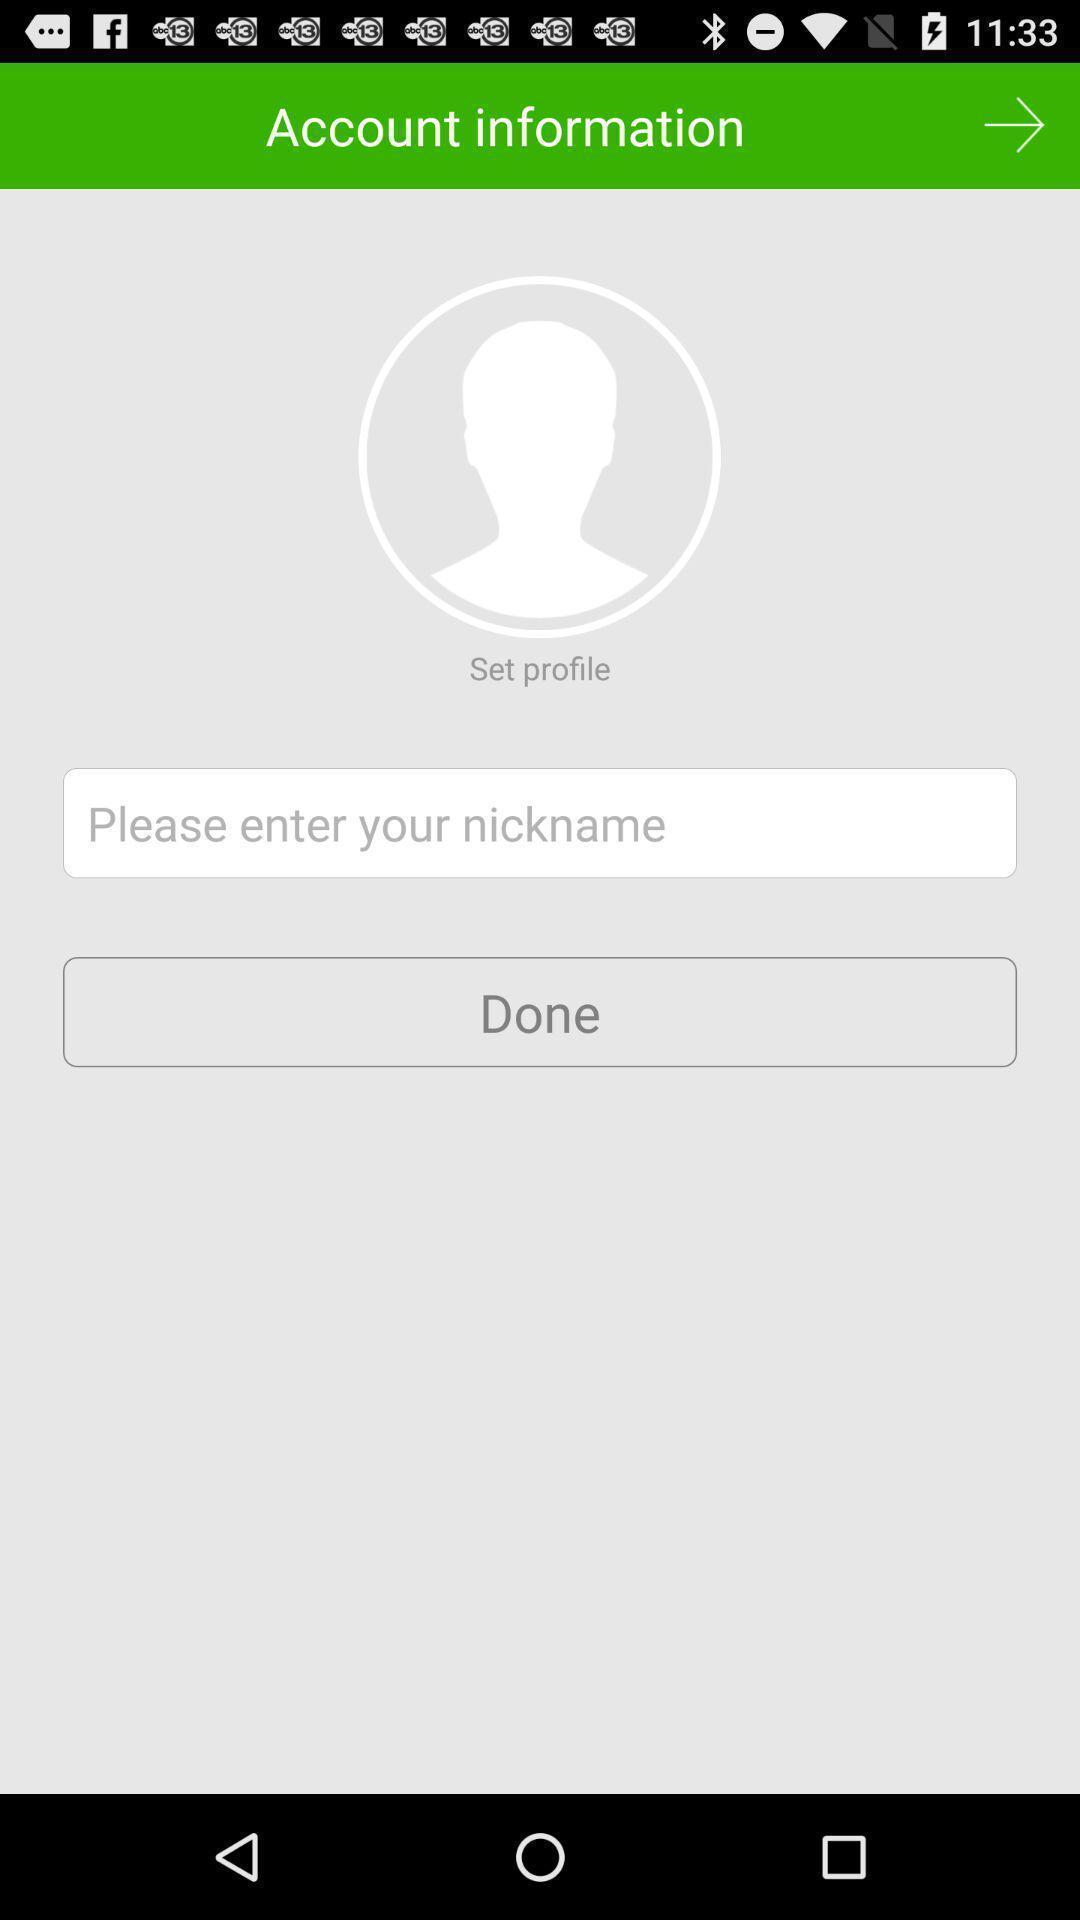Describe the visual elements of this screenshot. Page showing to enter account information in messaging app. 